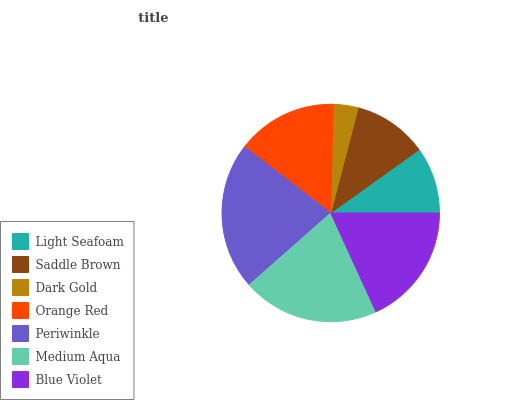Is Dark Gold the minimum?
Answer yes or no. Yes. Is Periwinkle the maximum?
Answer yes or no. Yes. Is Saddle Brown the minimum?
Answer yes or no. No. Is Saddle Brown the maximum?
Answer yes or no. No. Is Saddle Brown greater than Light Seafoam?
Answer yes or no. Yes. Is Light Seafoam less than Saddle Brown?
Answer yes or no. Yes. Is Light Seafoam greater than Saddle Brown?
Answer yes or no. No. Is Saddle Brown less than Light Seafoam?
Answer yes or no. No. Is Orange Red the high median?
Answer yes or no. Yes. Is Orange Red the low median?
Answer yes or no. Yes. Is Saddle Brown the high median?
Answer yes or no. No. Is Medium Aqua the low median?
Answer yes or no. No. 